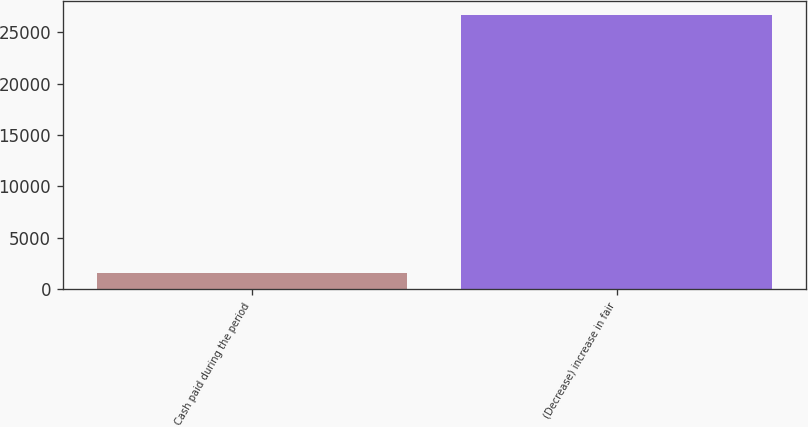Convert chart. <chart><loc_0><loc_0><loc_500><loc_500><bar_chart><fcel>Cash paid during the period<fcel>(Decrease) increase in fair<nl><fcel>1640<fcel>26646.5<nl></chart> 